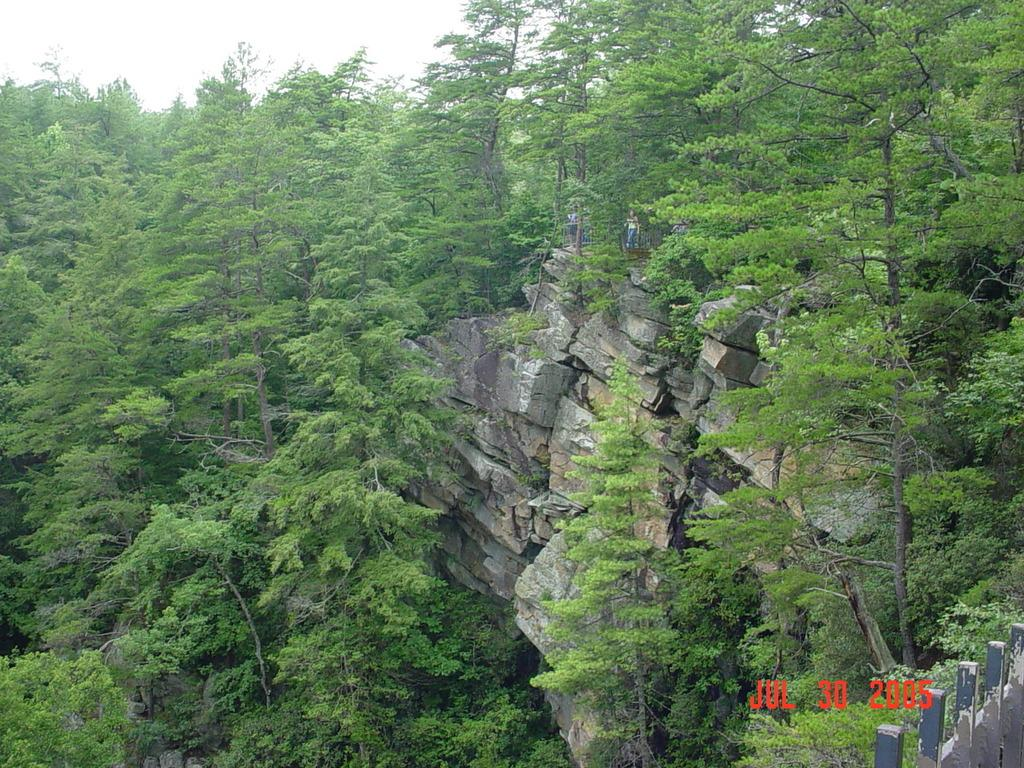What type of natural elements can be seen in the image? There are many trees and rocks in the image. What is visible in the background of the image? The sky is visible in the background of the image. Where is the fence located in the image? The fence is on the right side of the image. Can you see a town or basin in the image? There is no town or basin present in the image. Is there a swing visible in the image? There is no swing present in the image. 